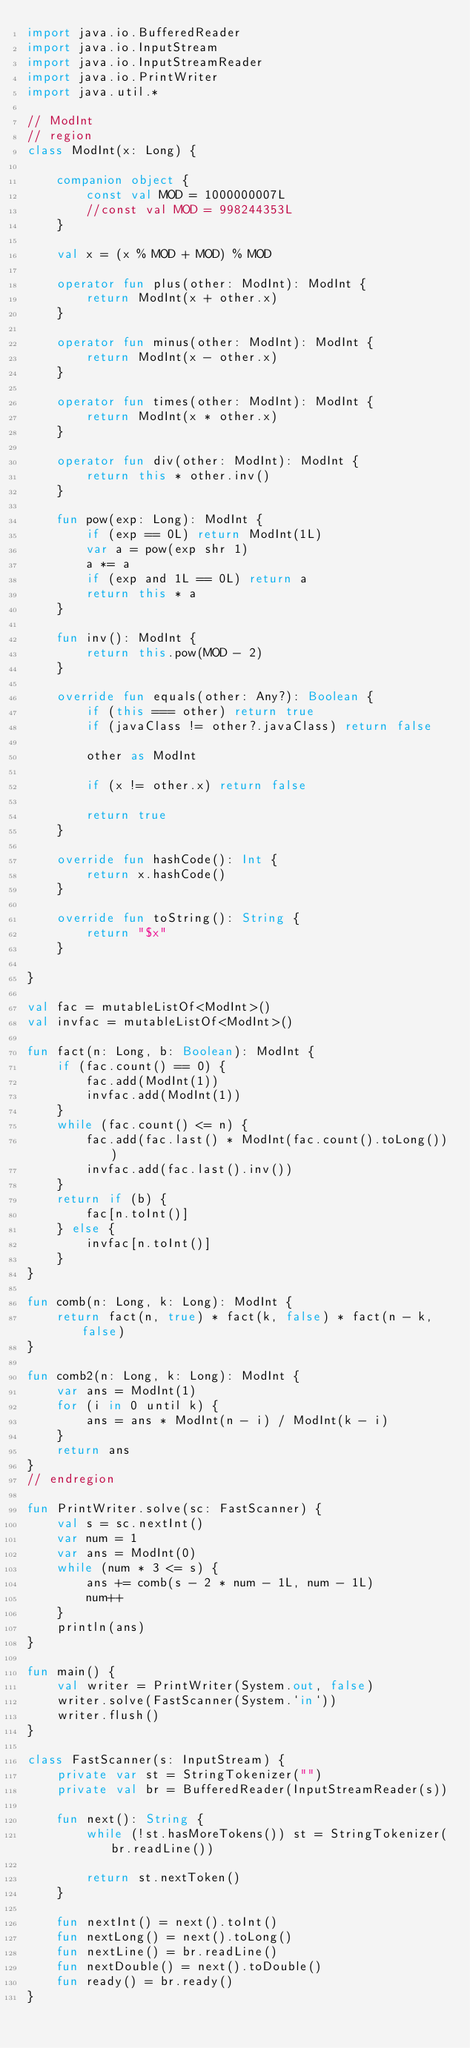Convert code to text. <code><loc_0><loc_0><loc_500><loc_500><_Kotlin_>import java.io.BufferedReader
import java.io.InputStream
import java.io.InputStreamReader
import java.io.PrintWriter
import java.util.*

// ModInt
// region
class ModInt(x: Long) {

    companion object {
        const val MOD = 1000000007L
        //const val MOD = 998244353L
    }

    val x = (x % MOD + MOD) % MOD

    operator fun plus(other: ModInt): ModInt {
        return ModInt(x + other.x)
    }

    operator fun minus(other: ModInt): ModInt {
        return ModInt(x - other.x)
    }

    operator fun times(other: ModInt): ModInt {
        return ModInt(x * other.x)
    }

    operator fun div(other: ModInt): ModInt {
        return this * other.inv()
    }

    fun pow(exp: Long): ModInt {
        if (exp == 0L) return ModInt(1L)
        var a = pow(exp shr 1)
        a *= a
        if (exp and 1L == 0L) return a
        return this * a
    }

    fun inv(): ModInt {
        return this.pow(MOD - 2)
    }

    override fun equals(other: Any?): Boolean {
        if (this === other) return true
        if (javaClass != other?.javaClass) return false

        other as ModInt

        if (x != other.x) return false

        return true
    }

    override fun hashCode(): Int {
        return x.hashCode()
    }

    override fun toString(): String {
        return "$x"
    }

}

val fac = mutableListOf<ModInt>()
val invfac = mutableListOf<ModInt>()

fun fact(n: Long, b: Boolean): ModInt {
    if (fac.count() == 0) {
        fac.add(ModInt(1))
        invfac.add(ModInt(1))
    }
    while (fac.count() <= n) {
        fac.add(fac.last() * ModInt(fac.count().toLong()))
        invfac.add(fac.last().inv())
    }
    return if (b) {
        fac[n.toInt()]
    } else {
        invfac[n.toInt()]
    }
}

fun comb(n: Long, k: Long): ModInt {
    return fact(n, true) * fact(k, false) * fact(n - k, false)
}

fun comb2(n: Long, k: Long): ModInt {
    var ans = ModInt(1)
    for (i in 0 until k) {
        ans = ans * ModInt(n - i) / ModInt(k - i)
    }
    return ans
}
// endregion

fun PrintWriter.solve(sc: FastScanner) {
    val s = sc.nextInt()
    var num = 1
    var ans = ModInt(0)
    while (num * 3 <= s) {
        ans += comb(s - 2 * num - 1L, num - 1L)
        num++
    }
    println(ans)
}

fun main() {
    val writer = PrintWriter(System.out, false)
    writer.solve(FastScanner(System.`in`))
    writer.flush()
}

class FastScanner(s: InputStream) {
    private var st = StringTokenizer("")
    private val br = BufferedReader(InputStreamReader(s))

    fun next(): String {
        while (!st.hasMoreTokens()) st = StringTokenizer(br.readLine())

        return st.nextToken()
    }

    fun nextInt() = next().toInt()
    fun nextLong() = next().toLong()
    fun nextLine() = br.readLine()
    fun nextDouble() = next().toDouble()
    fun ready() = br.ready()
}
</code> 